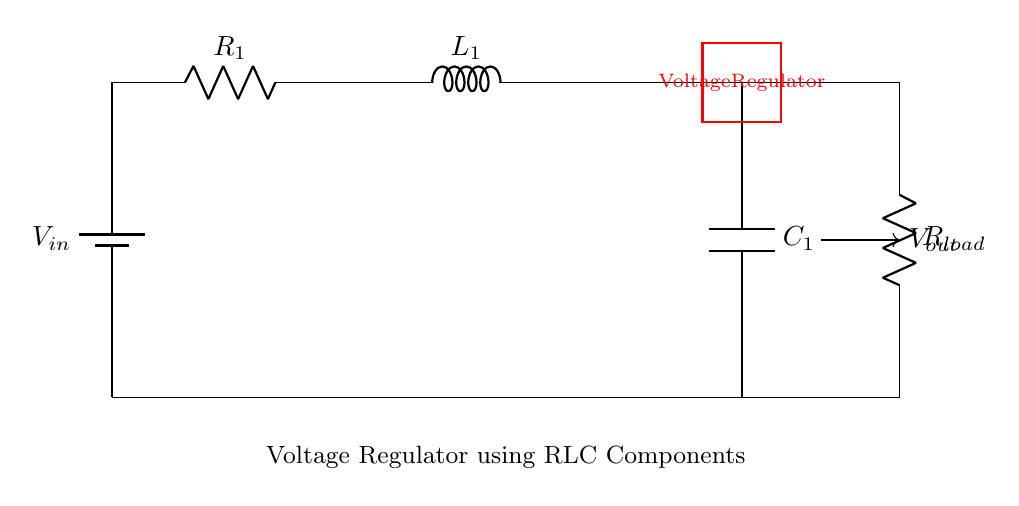What is the voltage source in this circuit? The voltage source is represented by the component labeled as "V in" in the diagram, which is the initial supply of electrical energy for the circuit.
Answer: V in What are the components used in this voltage regulator circuit? The components in the circuit are a resistor (R1), an inductor (L1), and a capacitor (C1), as indicated by their labels.
Answer: Resistor, inductor, capacitor What connects the load resistor to the output? The load resistor (R load) connects to the output through a direct path illustrated by the wire in the circuit, creating a loop with the capacitor.
Answer: Wire What role does the capacitor play in this circuit? The capacitor smooths the voltage output by storing charge and releasing it, which helps stabilize the output voltage delivered to the load.
Answer: Stabilization How does the inductor influence the current in the circuit? The inductor opposes changes in current due to its properties such as inductance, which helps maintain a constant current flow in conjunction with the capacitor and resistor.
Answer: Opposes changes What is the purpose of the voltage regulator in this circuit? The voltage regulator is designed to ensure a stable output voltage (V out) regardless of fluctuations in the input voltage or load conditions.
Answer: Stability What happens if the load resistance is increased? Increasing the load resistance generally decreases the current, which could lead to a higher voltage output if the circuit is functioning under a constant input voltage.
Answer: Higher voltage output 